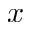Convert formula to latex. <formula><loc_0><loc_0><loc_500><loc_500>x</formula> 